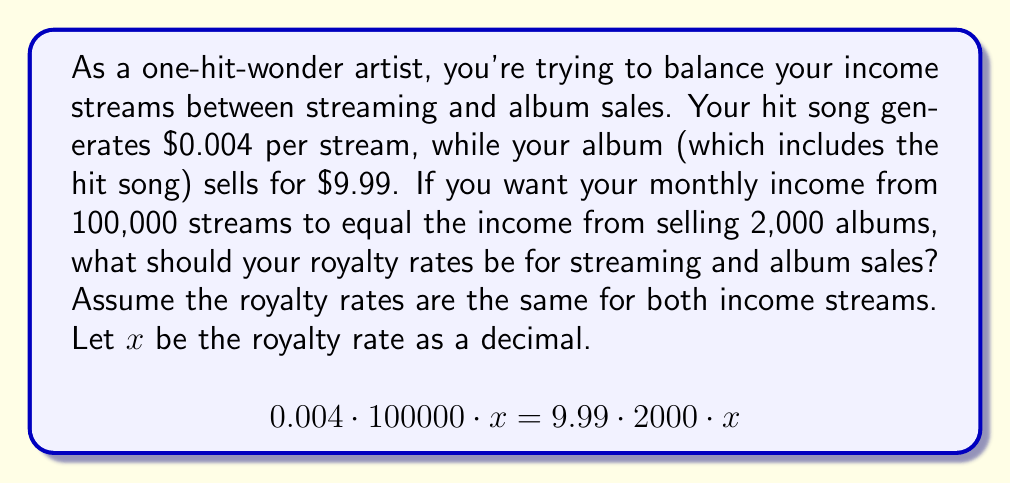Give your solution to this math problem. Let's solve this step-by-step:

1) First, let's set up the equation:
   $$0.004 \cdot 100000 \cdot x = 9.99 \cdot 2000 \cdot x$$

2) Simplify the left side:
   $$400x = 9.99 \cdot 2000 \cdot x$$

3) Simplify the right side:
   $$400x = 19980x$$

4) Subtract 400x from both sides:
   $$0 = 19580x$$

5) Divide both sides by 19580:
   $$0 = x$$

6) This result indicates that no royalty rate will make these two income streams equal. This is because the total revenue from 100,000 streams ($400) is much less than the total revenue from 2,000 album sales ($19,980).

7) To find a more realistic scenario, let's calculate the royalty rate that would give you the same income if you had 1,000,000 streams instead of 100,000:

   $$0.004 \cdot 1000000 \cdot x = 9.99 \cdot 2000 \cdot x$$
   $$4000x = 19980x$$
   $$4000x = 19980x$$
   $$0 = 15980x$$
   $$x = 0$$

8) Again, we see that no royalty rate will equalize these income streams. This suggests that streaming revenue is significantly lower than album sales revenue, even with a much higher number of streams.

9) To find a royalty rate that works, you would need to negotiate different rates for streaming and album sales. For example, if you want a 15% royalty on album sales, you would need a much higher percentage on streaming to equalize the income:

   $$0.004 \cdot 1000000 \cdot x = 9.99 \cdot 2000 \cdot 0.15$$
   $$4000x = 2997$$
   $$x = 0.74925 = 74.925\%$$

This shows that to equalize income, you would need about a 75% royalty rate on streaming if you have a 15% royalty rate on album sales.
Answer: There is no single royalty rate that will equalize the income from 100,000 streams and 2,000 album sales. The album sales generate significantly more revenue. To equalize income, you would need to negotiate different royalty rates for streaming and album sales. For example, with a 15% royalty on album sales, you would need approximately a 75% royalty on streaming to equalize income from 1,000,000 streams and 2,000 album sales. 